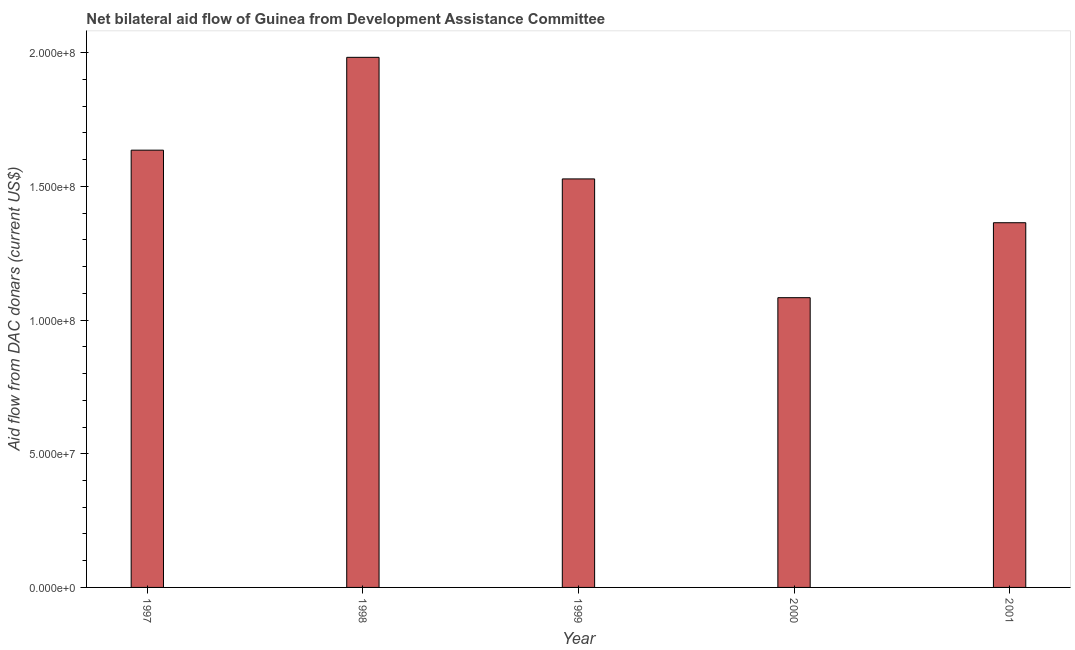What is the title of the graph?
Ensure brevity in your answer.  Net bilateral aid flow of Guinea from Development Assistance Committee. What is the label or title of the X-axis?
Give a very brief answer. Year. What is the label or title of the Y-axis?
Provide a succinct answer. Aid flow from DAC donars (current US$). What is the net bilateral aid flows from dac donors in 1998?
Offer a terse response. 1.98e+08. Across all years, what is the maximum net bilateral aid flows from dac donors?
Offer a very short reply. 1.98e+08. Across all years, what is the minimum net bilateral aid flows from dac donors?
Make the answer very short. 1.08e+08. In which year was the net bilateral aid flows from dac donors maximum?
Make the answer very short. 1998. In which year was the net bilateral aid flows from dac donors minimum?
Provide a short and direct response. 2000. What is the sum of the net bilateral aid flows from dac donors?
Provide a short and direct response. 7.60e+08. What is the difference between the net bilateral aid flows from dac donors in 1998 and 2001?
Make the answer very short. 6.19e+07. What is the average net bilateral aid flows from dac donors per year?
Offer a terse response. 1.52e+08. What is the median net bilateral aid flows from dac donors?
Ensure brevity in your answer.  1.53e+08. Do a majority of the years between 2000 and 2001 (inclusive) have net bilateral aid flows from dac donors greater than 150000000 US$?
Your response must be concise. No. What is the ratio of the net bilateral aid flows from dac donors in 1999 to that in 2000?
Your response must be concise. 1.41. Is the net bilateral aid flows from dac donors in 1997 less than that in 1998?
Give a very brief answer. Yes. Is the difference between the net bilateral aid flows from dac donors in 1998 and 2001 greater than the difference between any two years?
Provide a succinct answer. No. What is the difference between the highest and the second highest net bilateral aid flows from dac donors?
Give a very brief answer. 3.47e+07. What is the difference between the highest and the lowest net bilateral aid flows from dac donors?
Offer a terse response. 8.99e+07. What is the difference between two consecutive major ticks on the Y-axis?
Ensure brevity in your answer.  5.00e+07. Are the values on the major ticks of Y-axis written in scientific E-notation?
Make the answer very short. Yes. What is the Aid flow from DAC donars (current US$) of 1997?
Offer a terse response. 1.64e+08. What is the Aid flow from DAC donars (current US$) in 1998?
Your response must be concise. 1.98e+08. What is the Aid flow from DAC donars (current US$) of 1999?
Your answer should be compact. 1.53e+08. What is the Aid flow from DAC donars (current US$) of 2000?
Make the answer very short. 1.08e+08. What is the Aid flow from DAC donars (current US$) in 2001?
Offer a very short reply. 1.36e+08. What is the difference between the Aid flow from DAC donars (current US$) in 1997 and 1998?
Keep it short and to the point. -3.47e+07. What is the difference between the Aid flow from DAC donars (current US$) in 1997 and 1999?
Provide a succinct answer. 1.08e+07. What is the difference between the Aid flow from DAC donars (current US$) in 1997 and 2000?
Keep it short and to the point. 5.52e+07. What is the difference between the Aid flow from DAC donars (current US$) in 1997 and 2001?
Your answer should be very brief. 2.71e+07. What is the difference between the Aid flow from DAC donars (current US$) in 1998 and 1999?
Your response must be concise. 4.55e+07. What is the difference between the Aid flow from DAC donars (current US$) in 1998 and 2000?
Provide a short and direct response. 8.99e+07. What is the difference between the Aid flow from DAC donars (current US$) in 1998 and 2001?
Your answer should be compact. 6.19e+07. What is the difference between the Aid flow from DAC donars (current US$) in 1999 and 2000?
Ensure brevity in your answer.  4.44e+07. What is the difference between the Aid flow from DAC donars (current US$) in 1999 and 2001?
Offer a terse response. 1.64e+07. What is the difference between the Aid flow from DAC donars (current US$) in 2000 and 2001?
Your answer should be compact. -2.80e+07. What is the ratio of the Aid flow from DAC donars (current US$) in 1997 to that in 1998?
Provide a short and direct response. 0.82. What is the ratio of the Aid flow from DAC donars (current US$) in 1997 to that in 1999?
Give a very brief answer. 1.07. What is the ratio of the Aid flow from DAC donars (current US$) in 1997 to that in 2000?
Ensure brevity in your answer.  1.51. What is the ratio of the Aid flow from DAC donars (current US$) in 1997 to that in 2001?
Give a very brief answer. 1.2. What is the ratio of the Aid flow from DAC donars (current US$) in 1998 to that in 1999?
Provide a short and direct response. 1.3. What is the ratio of the Aid flow from DAC donars (current US$) in 1998 to that in 2000?
Offer a very short reply. 1.83. What is the ratio of the Aid flow from DAC donars (current US$) in 1998 to that in 2001?
Your answer should be very brief. 1.45. What is the ratio of the Aid flow from DAC donars (current US$) in 1999 to that in 2000?
Provide a succinct answer. 1.41. What is the ratio of the Aid flow from DAC donars (current US$) in 1999 to that in 2001?
Your answer should be very brief. 1.12. What is the ratio of the Aid flow from DAC donars (current US$) in 2000 to that in 2001?
Provide a short and direct response. 0.79. 